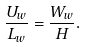<formula> <loc_0><loc_0><loc_500><loc_500>\frac { U _ { w } } { L _ { w } } = \frac { W _ { w } } { H } .</formula> 